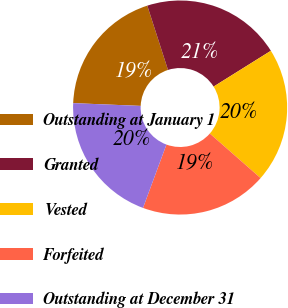<chart> <loc_0><loc_0><loc_500><loc_500><pie_chart><fcel>Outstanding at January 1<fcel>Granted<fcel>Vested<fcel>Forfeited<fcel>Outstanding at December 31<nl><fcel>19.39%<fcel>21.07%<fcel>20.35%<fcel>19.18%<fcel>20.02%<nl></chart> 